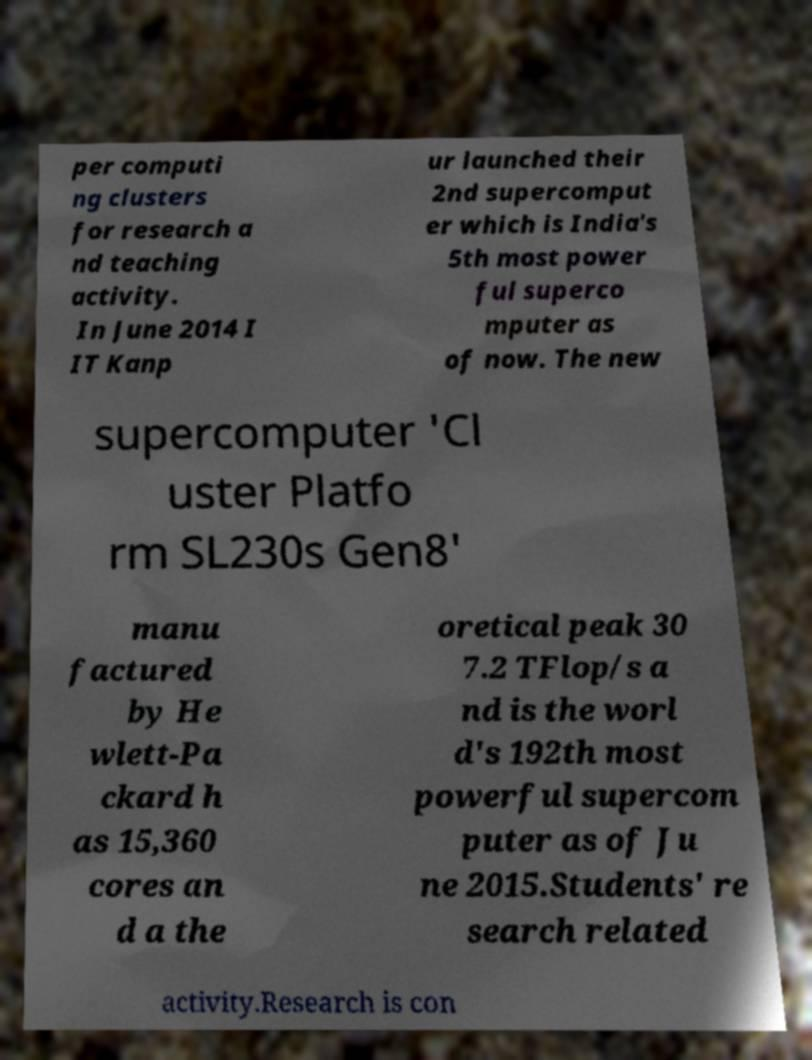I need the written content from this picture converted into text. Can you do that? per computi ng clusters for research a nd teaching activity. In June 2014 I IT Kanp ur launched their 2nd supercomput er which is India's 5th most power ful superco mputer as of now. The new supercomputer 'Cl uster Platfo rm SL230s Gen8' manu factured by He wlett-Pa ckard h as 15,360 cores an d a the oretical peak 30 7.2 TFlop/s a nd is the worl d's 192th most powerful supercom puter as of Ju ne 2015.Students' re search related activity.Research is con 